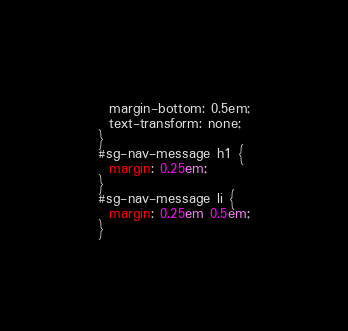Convert code to text. <code><loc_0><loc_0><loc_500><loc_500><_CSS_>  margin-bottom: 0.5em;
  text-transform: none;
}
#sg-nav-message h1 {
  margin: 0.25em;
}
#sg-nav-message li {
  margin: 0.25em 0.5em;
}
</code> 